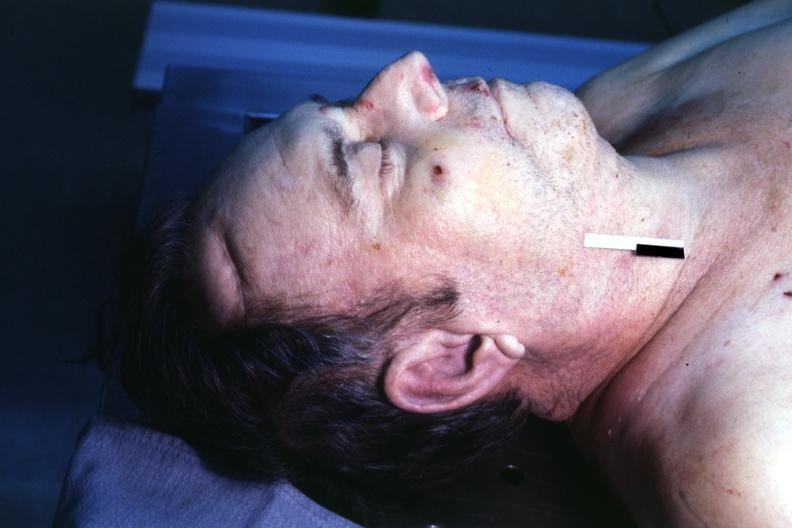s body on autopsy table lesion that supposedly predicts premature coronary disease easily seen?
Answer the question using a single word or phrase. Yes 